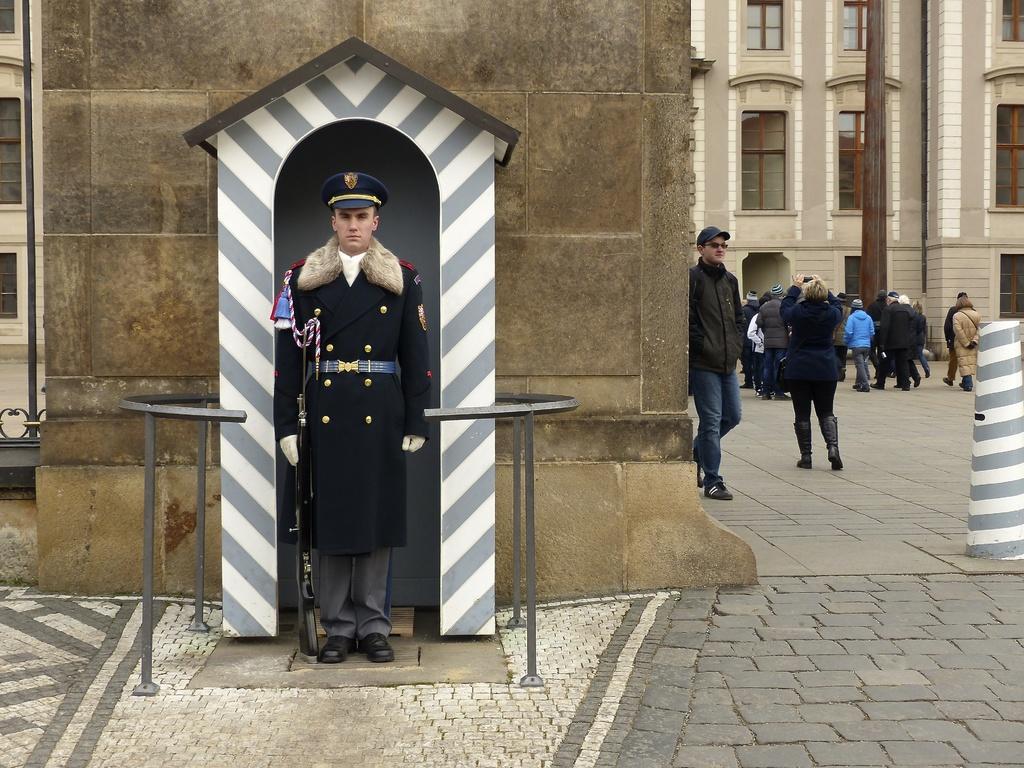Could you give a brief overview of what you see in this image? Here we can see a man is standing by holding a gun in his hand on the ground at a small room covered by a metal fence. In the background there is a wall,fence,poles,buildings,windows and few persons are walking on the ground. 